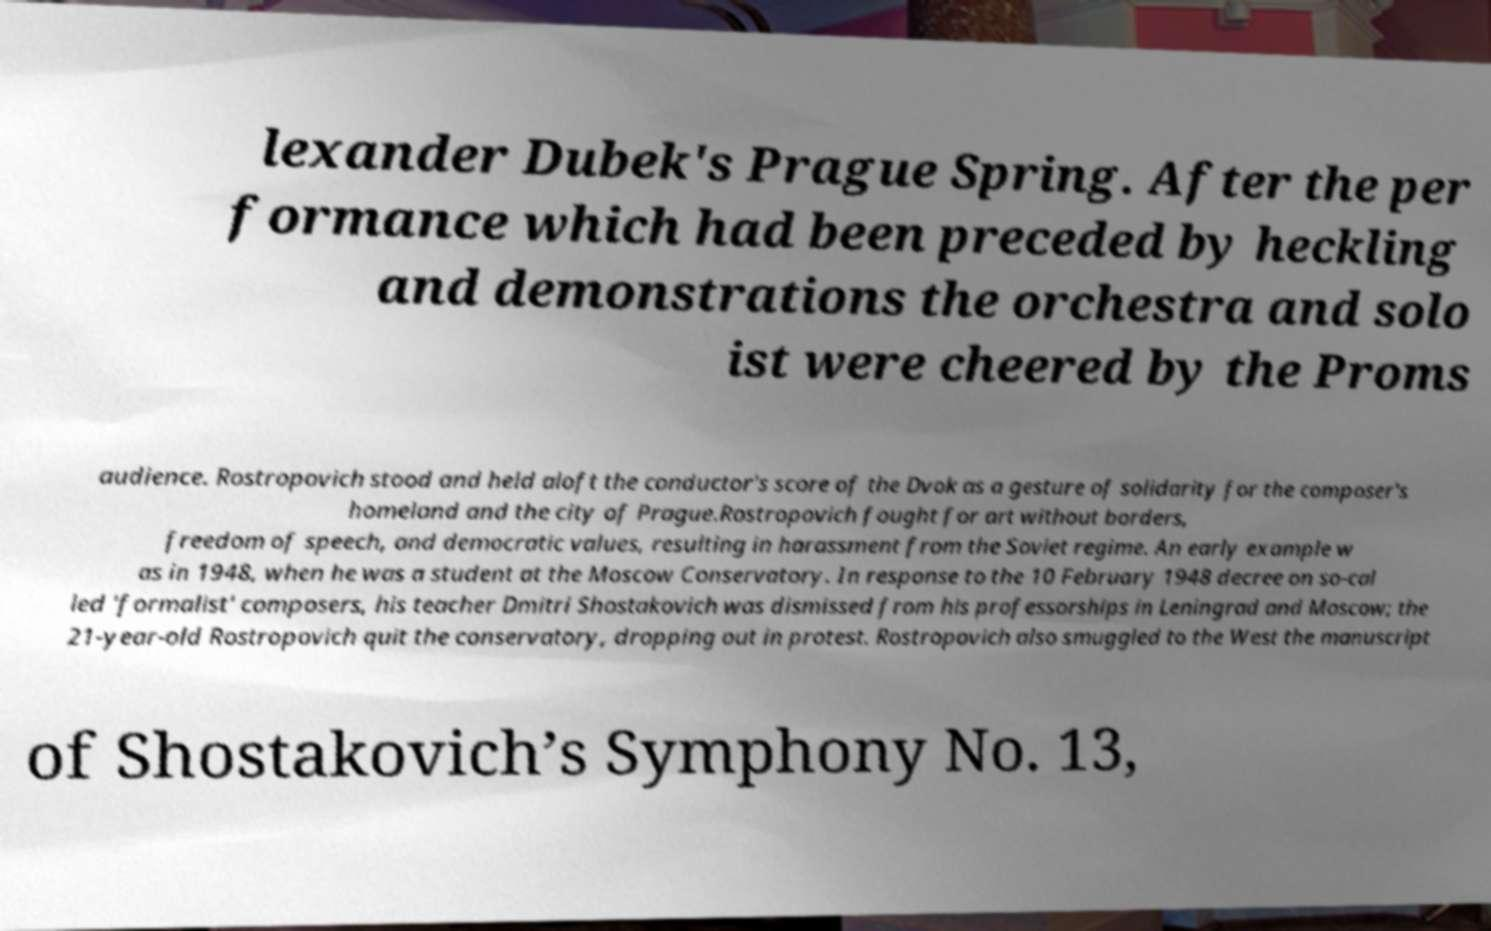Please identify and transcribe the text found in this image. lexander Dubek's Prague Spring. After the per formance which had been preceded by heckling and demonstrations the orchestra and solo ist were cheered by the Proms audience. Rostropovich stood and held aloft the conductor's score of the Dvok as a gesture of solidarity for the composer's homeland and the city of Prague.Rostropovich fought for art without borders, freedom of speech, and democratic values, resulting in harassment from the Soviet regime. An early example w as in 1948, when he was a student at the Moscow Conservatory. In response to the 10 February 1948 decree on so-cal led 'formalist' composers, his teacher Dmitri Shostakovich was dismissed from his professorships in Leningrad and Moscow; the 21-year-old Rostropovich quit the conservatory, dropping out in protest. Rostropovich also smuggled to the West the manuscript of Shostakovich’s Symphony No. 13, 